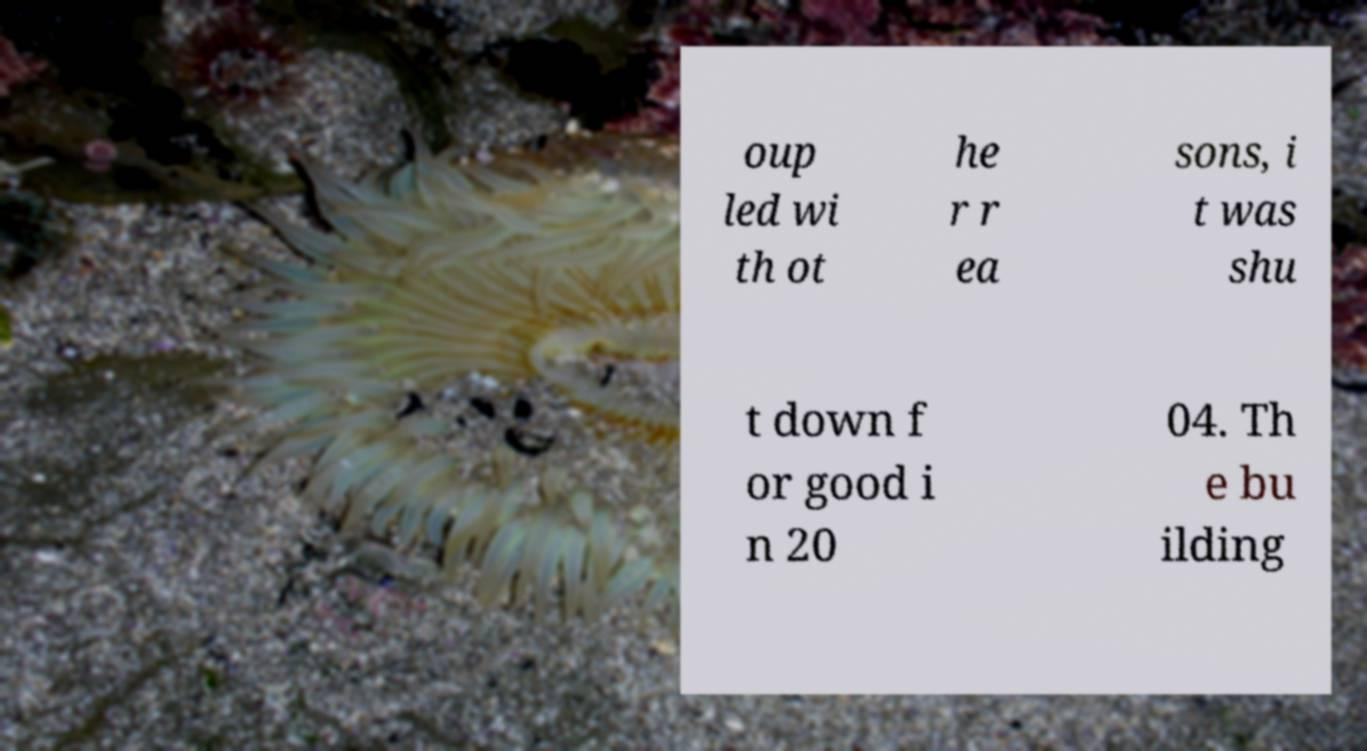Can you read and provide the text displayed in the image?This photo seems to have some interesting text. Can you extract and type it out for me? oup led wi th ot he r r ea sons, i t was shu t down f or good i n 20 04. Th e bu ilding 